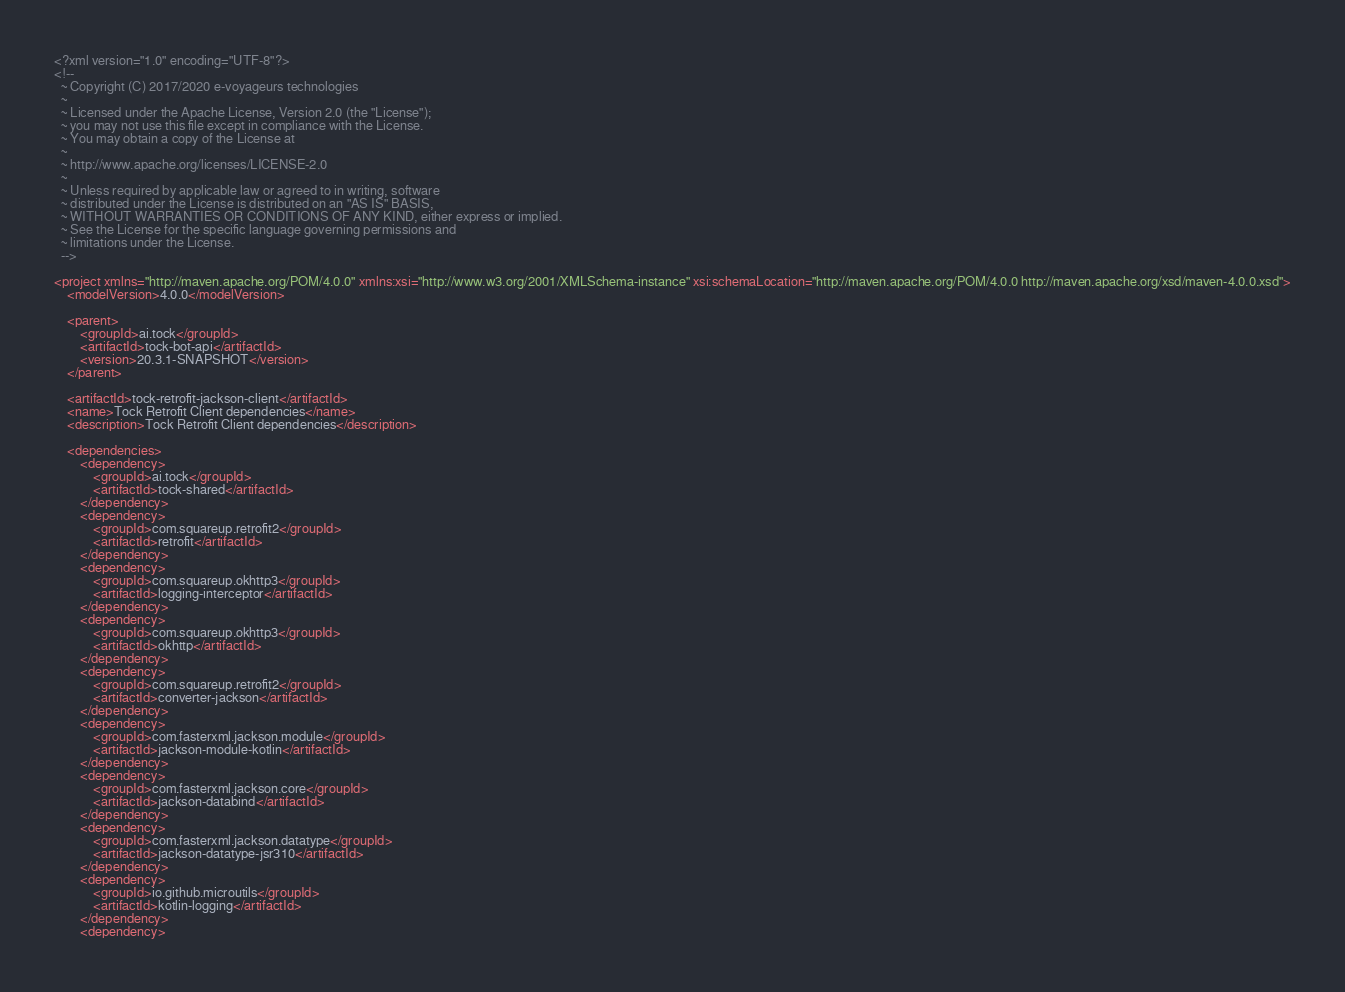<code> <loc_0><loc_0><loc_500><loc_500><_XML_><?xml version="1.0" encoding="UTF-8"?>
<!--
  ~ Copyright (C) 2017/2020 e-voyageurs technologies
  ~
  ~ Licensed under the Apache License, Version 2.0 (the "License");
  ~ you may not use this file except in compliance with the License.
  ~ You may obtain a copy of the License at
  ~
  ~ http://www.apache.org/licenses/LICENSE-2.0
  ~
  ~ Unless required by applicable law or agreed to in writing, software
  ~ distributed under the License is distributed on an "AS IS" BASIS,
  ~ WITHOUT WARRANTIES OR CONDITIONS OF ANY KIND, either express or implied.
  ~ See the License for the specific language governing permissions and
  ~ limitations under the License.
  -->

<project xmlns="http://maven.apache.org/POM/4.0.0" xmlns:xsi="http://www.w3.org/2001/XMLSchema-instance" xsi:schemaLocation="http://maven.apache.org/POM/4.0.0 http://maven.apache.org/xsd/maven-4.0.0.xsd">
    <modelVersion>4.0.0</modelVersion>

    <parent>
        <groupId>ai.tock</groupId>
        <artifactId>tock-bot-api</artifactId>
        <version>20.3.1-SNAPSHOT</version>
    </parent>

    <artifactId>tock-retrofit-jackson-client</artifactId>
    <name>Tock Retrofit Client dependencies</name>
    <description>Tock Retrofit Client dependencies</description>

    <dependencies>
        <dependency>
            <groupId>ai.tock</groupId>
            <artifactId>tock-shared</artifactId>
        </dependency>
        <dependency>
            <groupId>com.squareup.retrofit2</groupId>
            <artifactId>retrofit</artifactId>
        </dependency>
        <dependency>
            <groupId>com.squareup.okhttp3</groupId>
            <artifactId>logging-interceptor</artifactId>
        </dependency>
        <dependency>
            <groupId>com.squareup.okhttp3</groupId>
            <artifactId>okhttp</artifactId>
        </dependency>
        <dependency>
            <groupId>com.squareup.retrofit2</groupId>
            <artifactId>converter-jackson</artifactId>
        </dependency>
        <dependency>
            <groupId>com.fasterxml.jackson.module</groupId>
            <artifactId>jackson-module-kotlin</artifactId>
        </dependency>
        <dependency>
            <groupId>com.fasterxml.jackson.core</groupId>
            <artifactId>jackson-databind</artifactId>
        </dependency>
        <dependency>
            <groupId>com.fasterxml.jackson.datatype</groupId>
            <artifactId>jackson-datatype-jsr310</artifactId>
        </dependency>
        <dependency>
            <groupId>io.github.microutils</groupId>
            <artifactId>kotlin-logging</artifactId>
        </dependency>
        <dependency></code> 